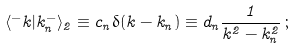<formula> <loc_0><loc_0><loc_500><loc_500>\langle ^ { - } k | k _ { n } ^ { - } \rangle _ { 2 } \equiv c _ { n } \delta ( k - k _ { n } ) \equiv d _ { n } \frac { 1 } { k ^ { 2 } - k _ { n } ^ { 2 } } \, ;</formula> 